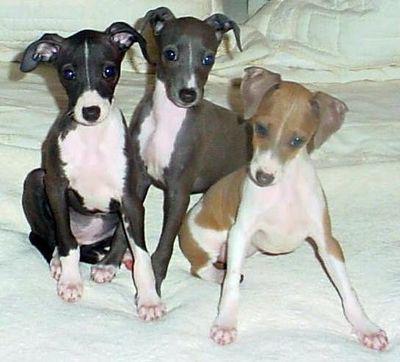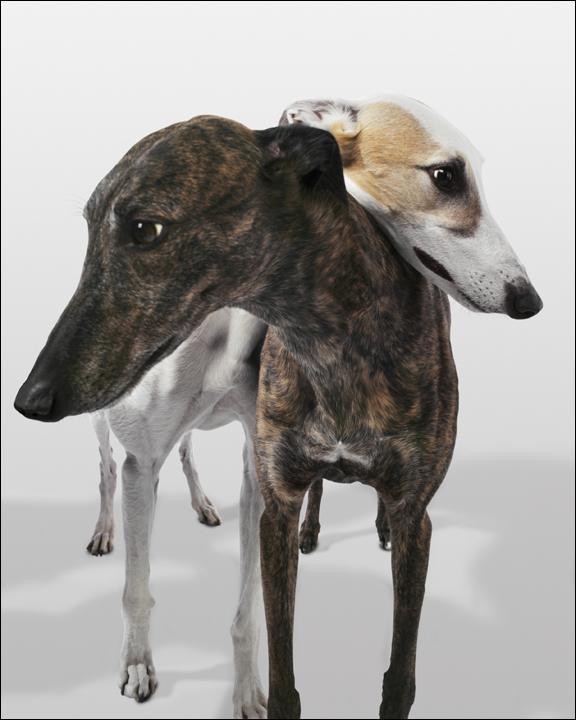The first image is the image on the left, the second image is the image on the right. Given the left and right images, does the statement "Each image contains exactly three hounds, including one image of dogs posed in a horizontal row." hold true? Answer yes or no. No. The first image is the image on the left, the second image is the image on the right. Analyze the images presented: Is the assertion "There are six dogs in total." valid? Answer yes or no. No. 